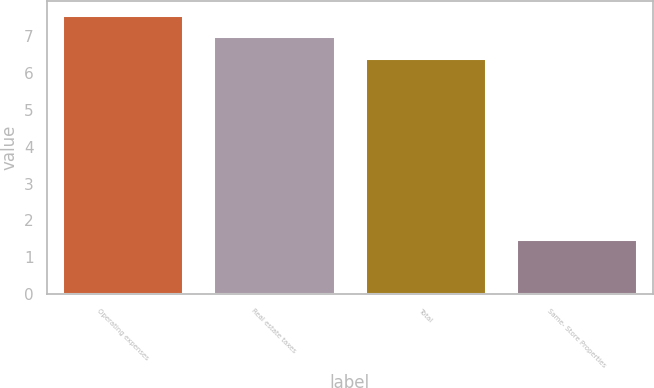Convert chart to OTSL. <chart><loc_0><loc_0><loc_500><loc_500><bar_chart><fcel>Operating expenses<fcel>Real estate taxes<fcel>Total<fcel>Same- Store Properties<nl><fcel>7.58<fcel>6.99<fcel>6.4<fcel>1.5<nl></chart> 